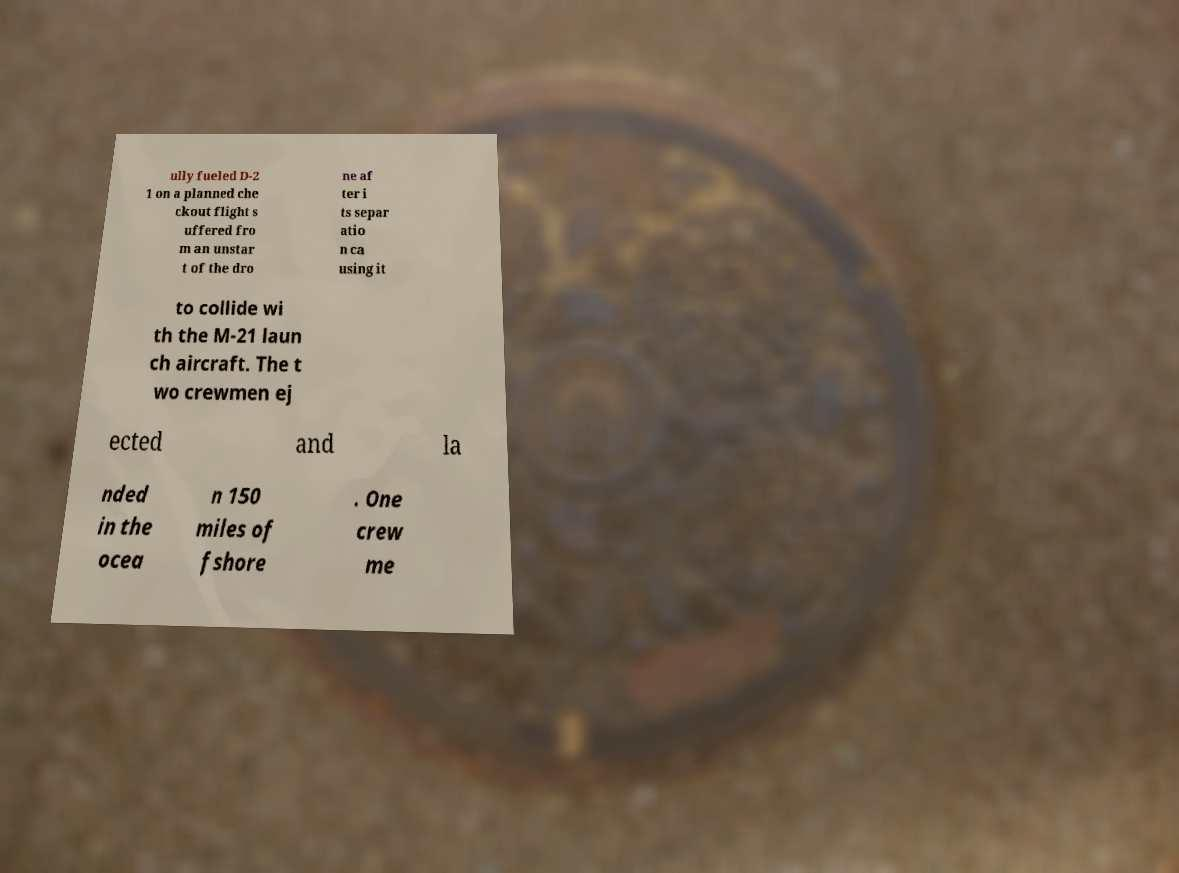Could you assist in decoding the text presented in this image and type it out clearly? ully fueled D-2 1 on a planned che ckout flight s uffered fro m an unstar t of the dro ne af ter i ts separ atio n ca using it to collide wi th the M-21 laun ch aircraft. The t wo crewmen ej ected and la nded in the ocea n 150 miles of fshore . One crew me 